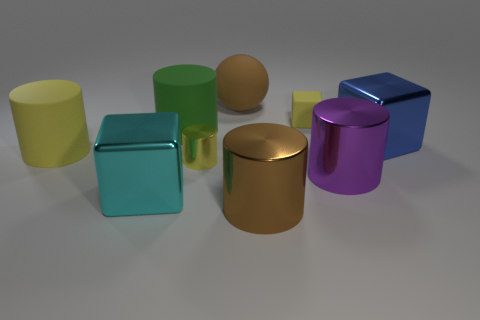Is the number of purple cylinders that are to the left of the sphere greater than the number of small red matte cubes?
Give a very brief answer. No. What is the color of the large cube on the right side of the purple shiny thing?
Make the answer very short. Blue. Is the size of the cyan shiny cube the same as the blue shiny object?
Keep it short and to the point. Yes. The green matte cylinder has what size?
Offer a very short reply. Large. There is a large thing that is the same color as the sphere; what shape is it?
Keep it short and to the point. Cylinder. Is the number of yellow metal objects greater than the number of yellow cylinders?
Your response must be concise. No. What is the color of the block left of the large brown object that is in front of the large metallic block in front of the blue cube?
Provide a short and direct response. Cyan. Does the small yellow thing that is to the left of the rubber sphere have the same shape as the cyan thing?
Keep it short and to the point. No. There is a ball that is the same size as the brown cylinder; what color is it?
Give a very brief answer. Brown. How many metal cylinders are there?
Provide a succinct answer. 3. 